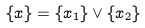Convert formula to latex. <formula><loc_0><loc_0><loc_500><loc_500>\{ \AA x \} = \{ \AA x _ { 1 } \} \vee \{ \AA x _ { 2 } \}</formula> 